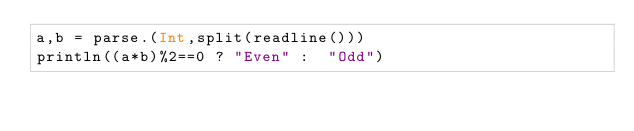Convert code to text. <code><loc_0><loc_0><loc_500><loc_500><_Julia_>a,b = parse.(Int,split(readline()))
println((a*b)%2==0 ? "Even" :  "Odd")</code> 